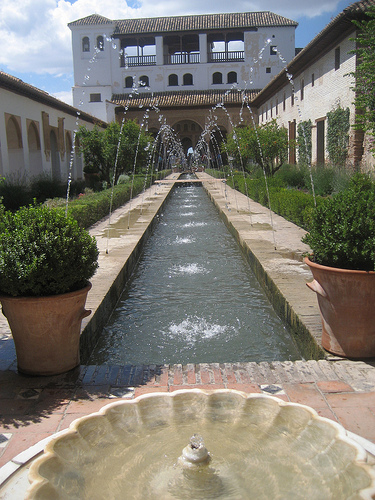<image>
Can you confirm if the water is next to the plant? Yes. The water is positioned adjacent to the plant, located nearby in the same general area. 